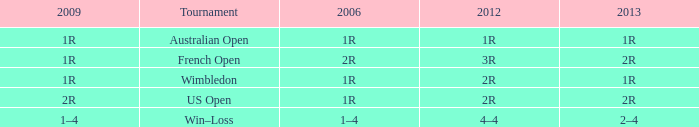What is the 2006 when the 2013 is 2r, and a Tournament was the us open? 1R. 